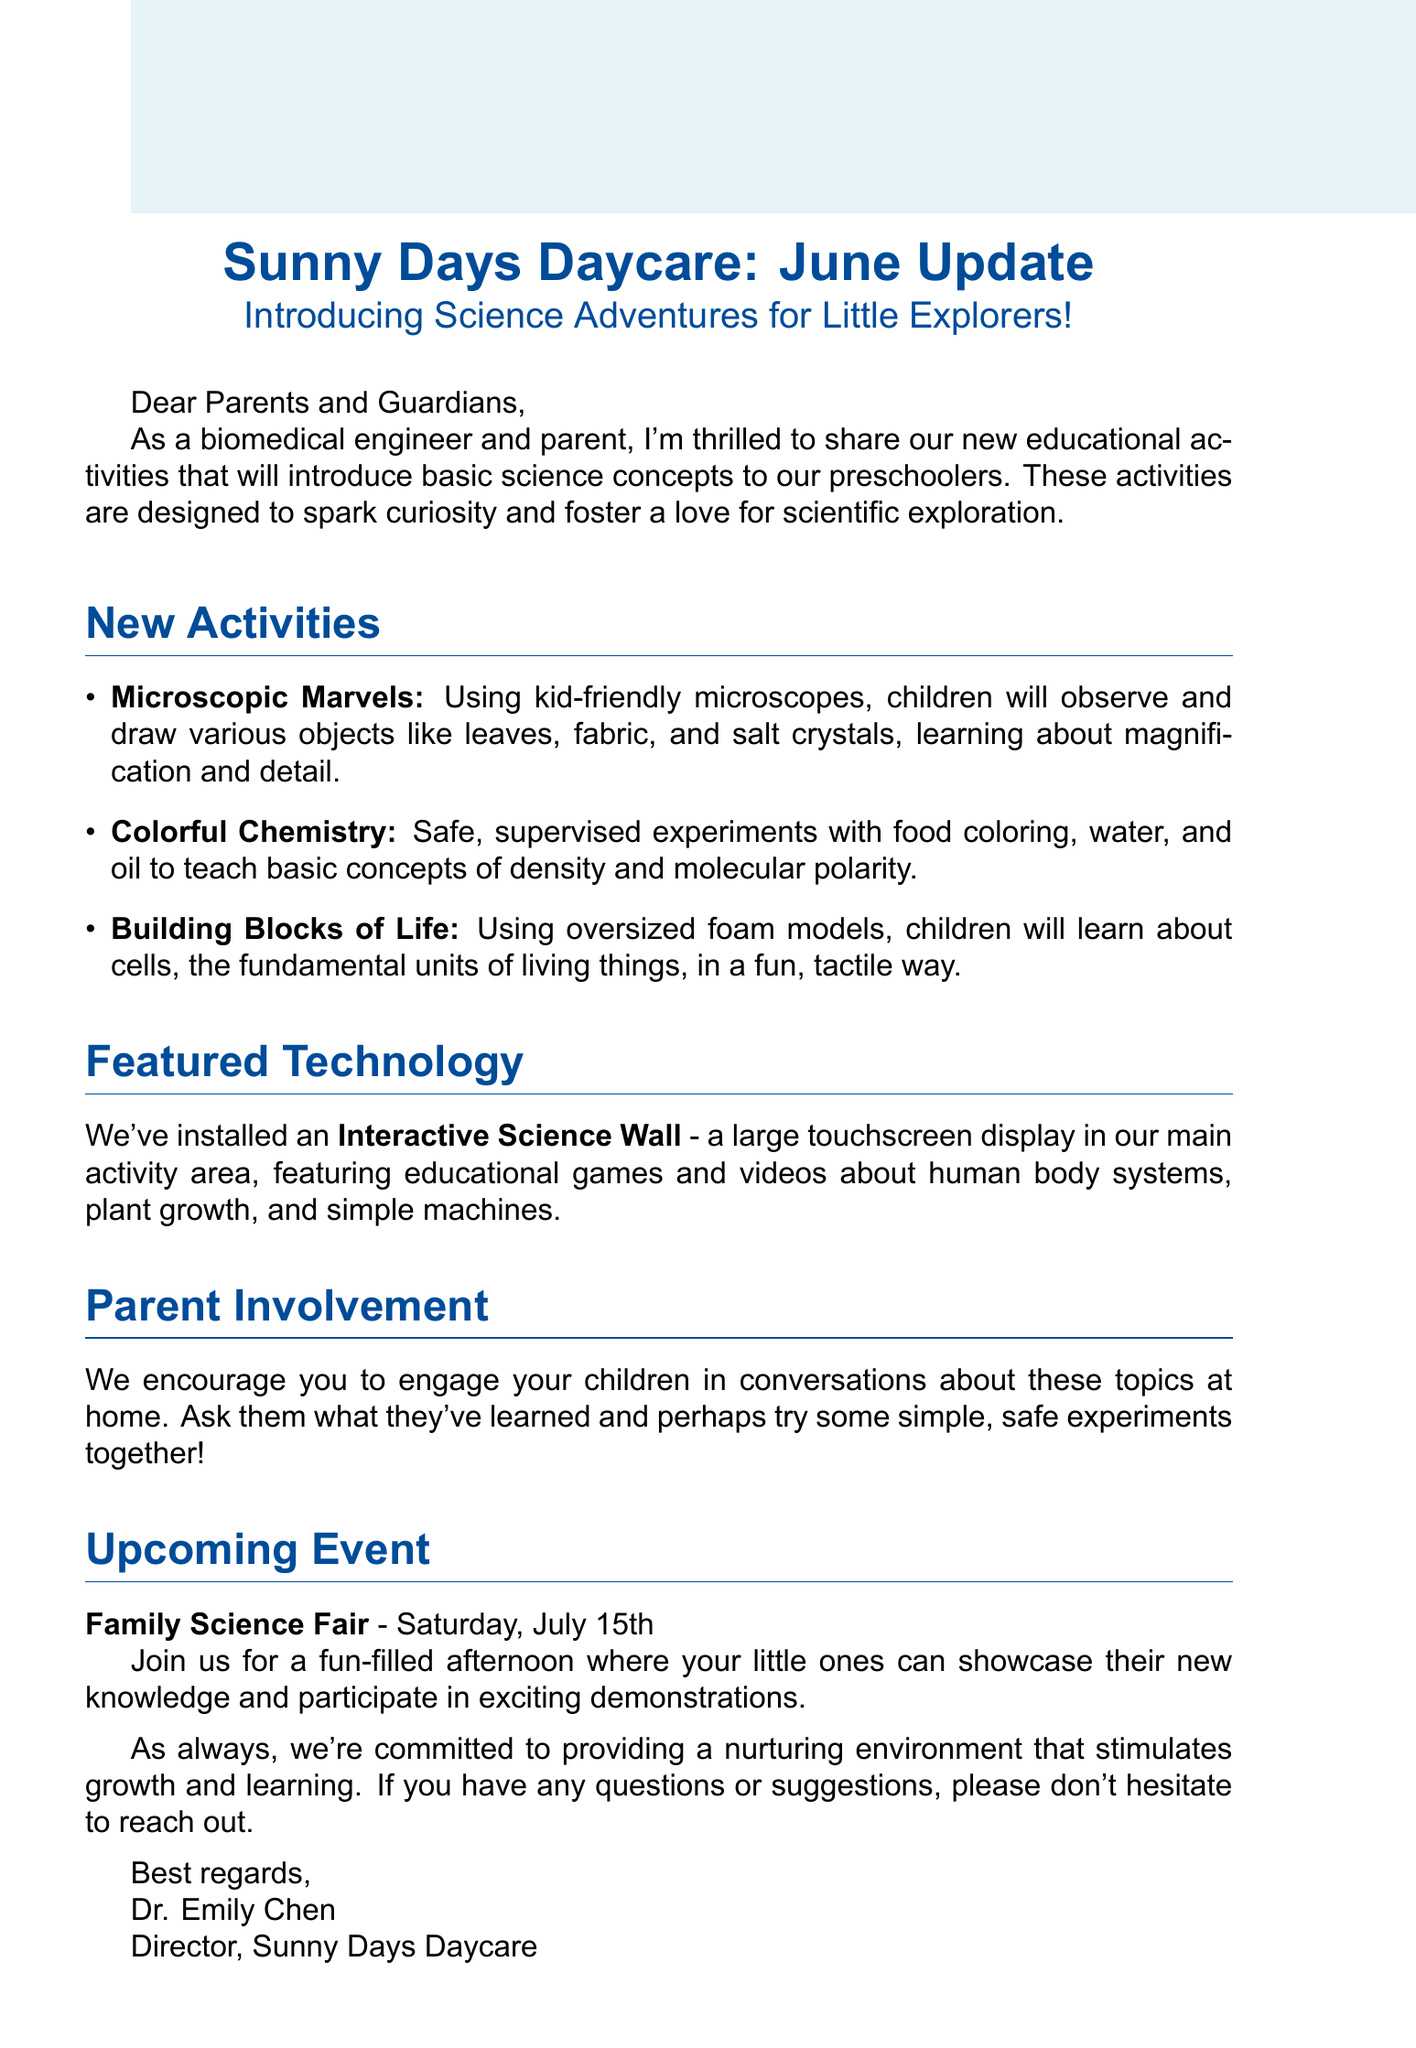What is the subject of the email? The subject of the email is stated at the beginning and captures the main theme of the update.
Answer: Sunny Days Daycare: June Update - Introducing Science Adventures for Little Explorers! What activity involves microscopes? The email lists the activities for preschoolers, one of which specifically mentions the use of microscopes.
Answer: Microscopic Marvels What is the date of the Family Science Fair? The upcoming event is detailed in the email along with its date.
Answer: Saturday, July 15th What educational technology was installed? The email highlights a specific technology that supports the new educational activities.
Answer: Interactive Science Wall How many new activities are introduced? The email outlines the number of activities aimed at introducing science concepts to the children.
Answer: Three Why should parents engage their children at home? The email mentions the importance of parent-child interaction regarding the new topics introduced at daycare.
Answer: To discuss what they've learned What safety aspect is mentioned in the Colorful Chemistry activity? The description of one of the activities explicitly mentions a key safety measure.
Answer: Safe, supervised experiments What fundamental units of living things are taught in the activities? The email describes an activity that focuses on a biological concept central to life sciences.
Answer: Cells 